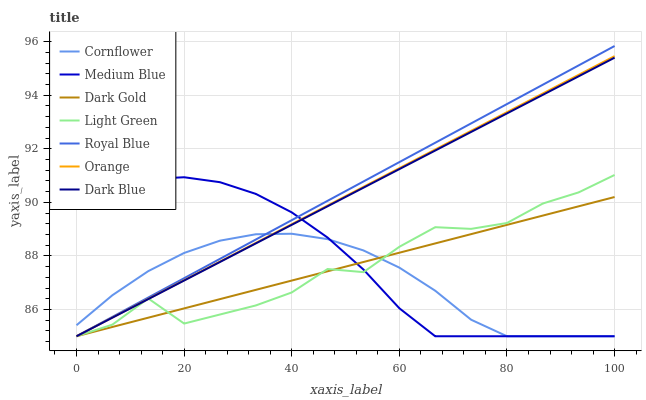Does Cornflower have the minimum area under the curve?
Answer yes or no. Yes. Does Royal Blue have the maximum area under the curve?
Answer yes or no. Yes. Does Dark Gold have the minimum area under the curve?
Answer yes or no. No. Does Dark Gold have the maximum area under the curve?
Answer yes or no. No. Is Dark Blue the smoothest?
Answer yes or no. Yes. Is Light Green the roughest?
Answer yes or no. Yes. Is Dark Gold the smoothest?
Answer yes or no. No. Is Dark Gold the roughest?
Answer yes or no. No. Does Cornflower have the lowest value?
Answer yes or no. Yes. Does Royal Blue have the highest value?
Answer yes or no. Yes. Does Dark Gold have the highest value?
Answer yes or no. No. Does Medium Blue intersect Cornflower?
Answer yes or no. Yes. Is Medium Blue less than Cornflower?
Answer yes or no. No. Is Medium Blue greater than Cornflower?
Answer yes or no. No. 